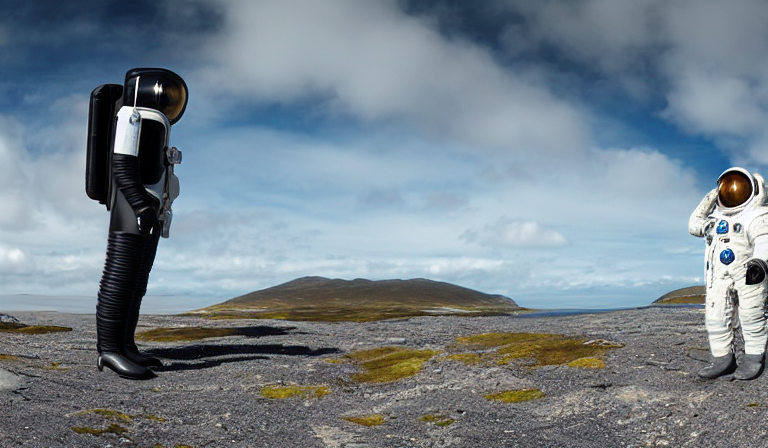What can be implied about the context of this surreal scene? The image presents a dreamlike or conceptual art scene where one of the figures represents a traditional astronaut and the other transforms the human body into a camera. It suggests themes of observation, human exploration, and perhaps a comment on how we record and perceive our environment, emphasizing a blend between humanity and technology within a barren, otherworldly landscape. 